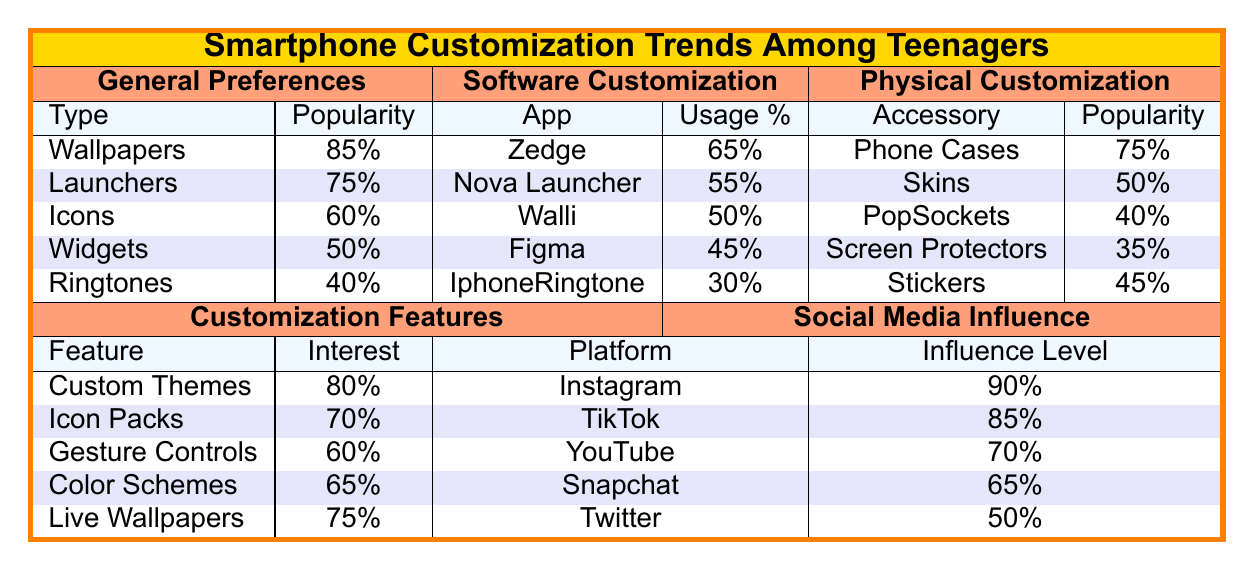What is the most popular customization type among teenagers? The customization types listed are Wallpapers, Launchers, Icons, Widgets, and Ringtones. Wallpapers have the highest popularity at 85%.
Answer: Wallpapers Which software customization app has the highest usage percentage? The apps listed are Zedge, Nova Launcher, Walli, Figma, and IphoneRingtone. Zedge has the highest usage percentage at 65%.
Answer: Zedge How many accessories are listed under physical customization? The table lists Phone Cases, Skins, PopSockets, Screen Protectors, and Stickers, which totals 5 accessories.
Answer: 5 What is the interest level in Custom Themes? The interest level for Custom Themes is given in the table, which is 80%.
Answer: 80% Which accessory has the lowest popularity? The accessories listed are Phone Cases, Skins, PopSockets, Screen Protectors, and Stickers. Screen Protectors have the lowest popularity at 35%.
Answer: Screen Protectors Which social media platform has the highest influence level? The platforms listed are Instagram, TikTok, YouTube, Snapchat, and Twitter. Instagram has the highest influence level at 90%.
Answer: Instagram What is the average popularity of customization types? The popularity values are 85, 75, 60, 50, and 40. The sum is 85 + 75 + 60 + 50 + 40 = 310, and dividing by 5 gives an average of 310 / 5 = 62.
Answer: 62 Is the popularity of Skins higher than that of PopSockets? The popularity of Skins is 50%, and for PopSockets, it is 40%. Since 50% is greater than 40%, the statement is true.
Answer: Yes What is the difference in usage percentage between Zedge and IphoneRingtone? Zedge has a usage percentage of 65%, and IphoneRingtone has 30%. The difference is 65 - 30 = 35.
Answer: 35 How many influencers have more than 10 million followers? The listed influencers with their follow counts are Casey Neistat (12), NikkieTutorials (14), Marques Brownlee (16), Safiya Nygaard (8), and Lilly Singh (9). The influencers with over 10 million followers are Casey Neistat, NikkieTutorials, and Marques Brownlee, totaling 3.
Answer: 3 